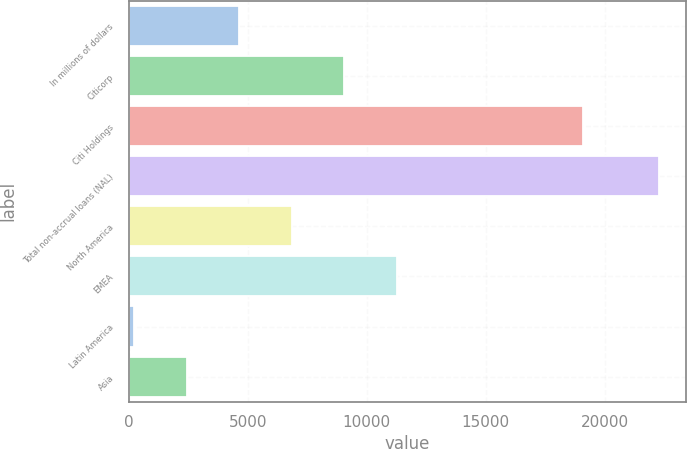<chart> <loc_0><loc_0><loc_500><loc_500><bar_chart><fcel>In millions of dollars<fcel>Citicorp<fcel>Citi Holdings<fcel>Total non-accrual loans (NAL)<fcel>North America<fcel>EMEA<fcel>Latin America<fcel>Asia<nl><fcel>4642.6<fcel>9056.2<fcel>19104<fcel>22297<fcel>6849.4<fcel>11263<fcel>229<fcel>2435.8<nl></chart> 